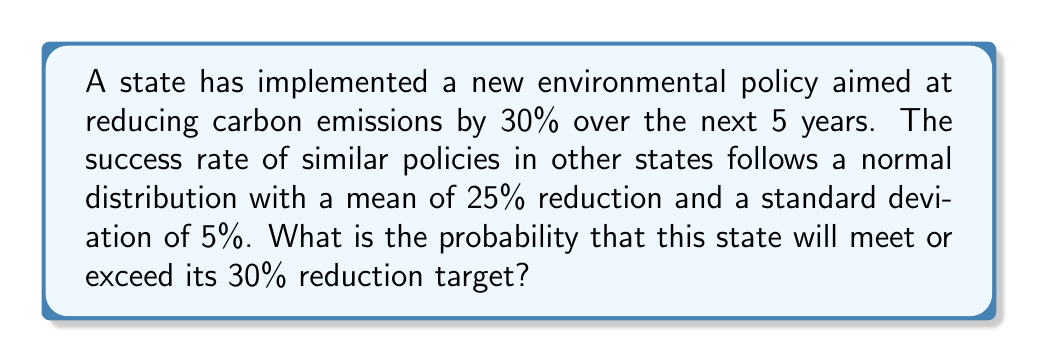Show me your answer to this math problem. To solve this problem, we need to use the properties of the normal distribution and calculate the z-score for the target value. Then, we can use a standard normal table or the error function to find the probability.

Given:
- Target reduction: 30%
- Mean reduction: $\mu = 25\%$
- Standard deviation: $\sigma = 5\%$

Step 1: Calculate the z-score
The z-score represents how many standard deviations the target value is from the mean.

$$z = \frac{x - \mu}{\sigma}$$

Where:
$x$ = target value
$\mu$ = mean
$\sigma$ = standard deviation

$$z = \frac{30 - 25}{5} = 1$$

Step 2: Calculate the probability
We want to find the probability of achieving a reduction greater than or equal to 30%, which is equivalent to finding the area under the normal curve to the right of z = 1.

For a standard normal distribution, we can use the error function (erf) to calculate this probability:

$$P(X \geq 30) = \frac{1}{2} - \frac{1}{2} \cdot \text{erf}\left(\frac{z}{\sqrt{2}}\right)$$

$$P(X \geq 30) = \frac{1}{2} - \frac{1}{2} \cdot \text{erf}\left(\frac{1}{\sqrt{2}}\right)$$

$$P(X \geq 30) \approx 0.1587$$

Therefore, the probability of meeting or exceeding the 30% reduction target is approximately 0.1587 or 15.87%.
Answer: The probability of meeting or exceeding the 30% carbon emission reduction target is approximately 0.1587 or 15.87%. 